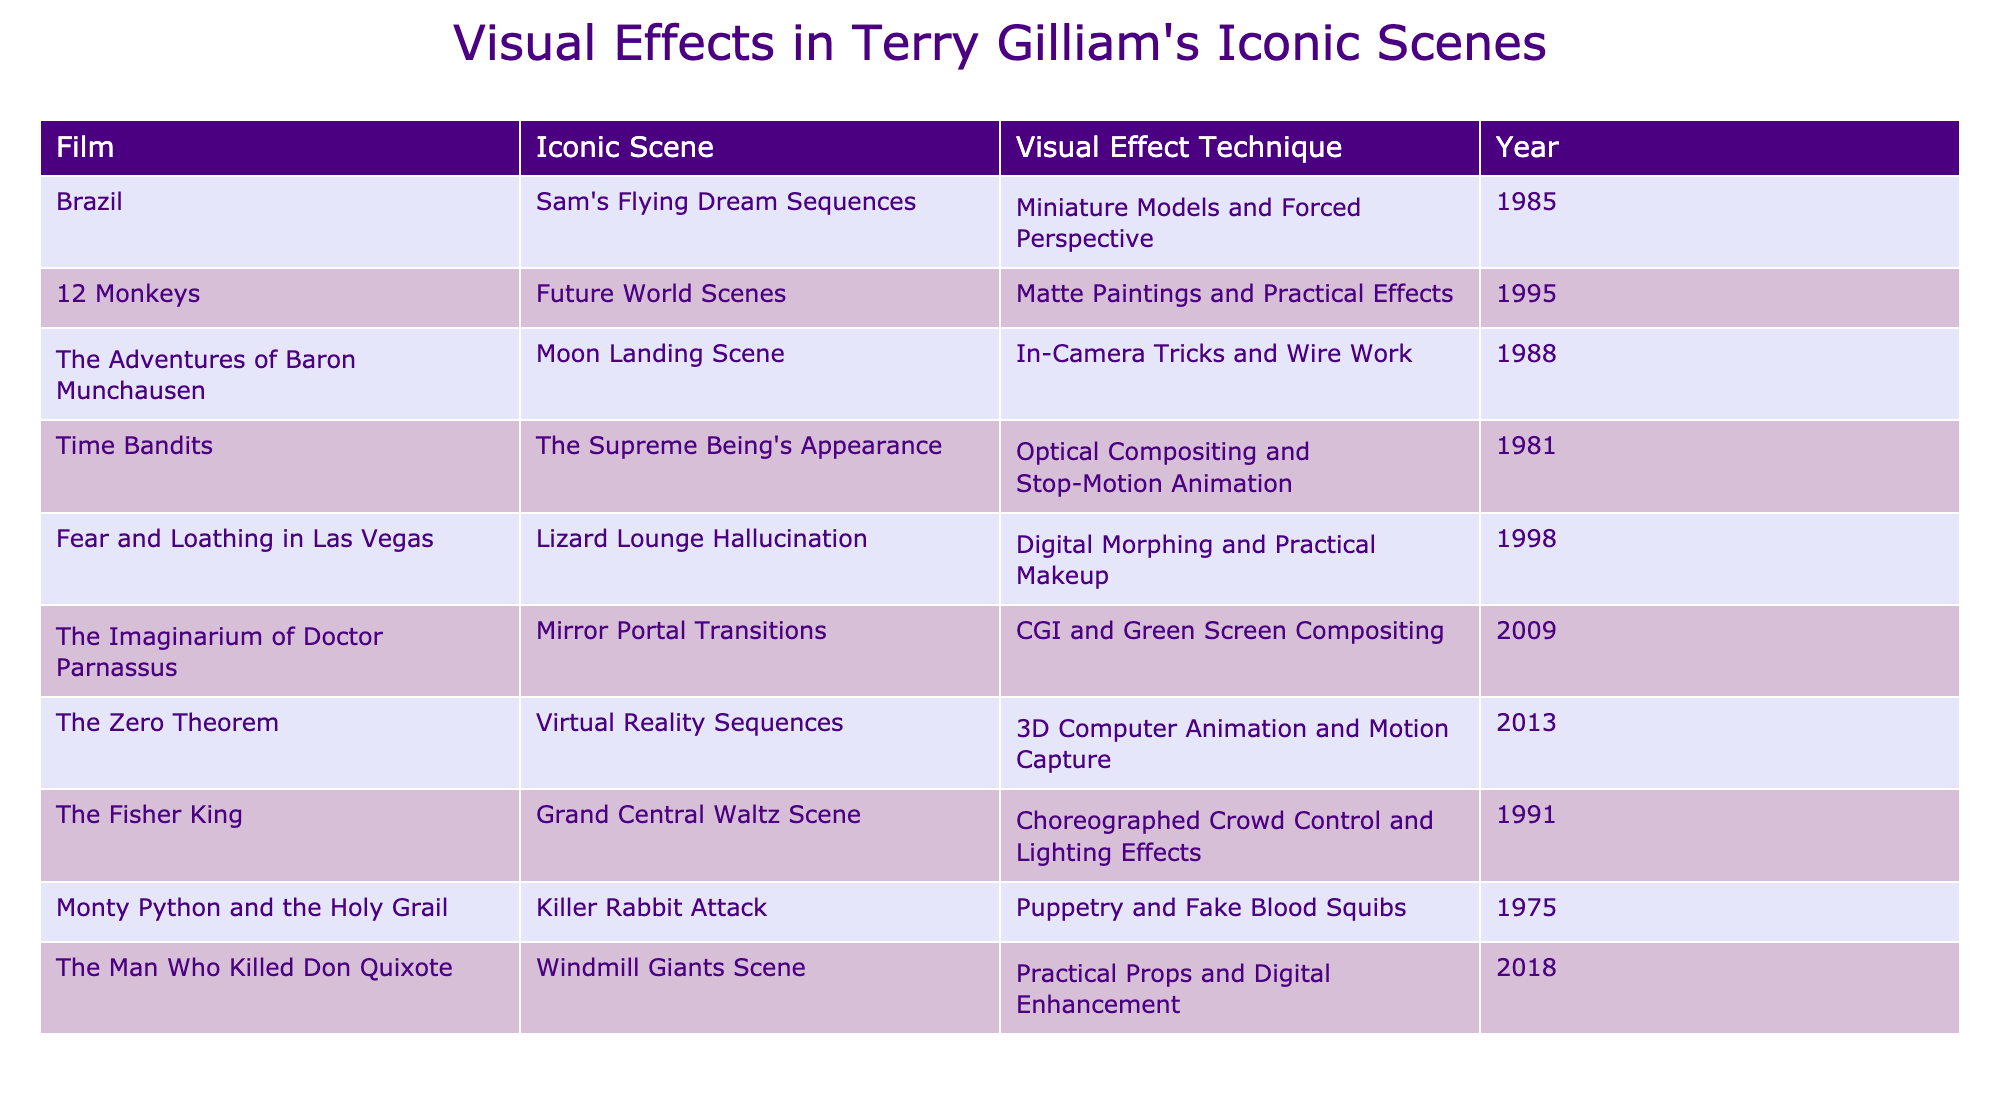What visual effect technique is used in Brazil's iconic scene? The table indicates that "Miniature Models and Forced Perspective" is the visual effect technique employed in the iconic scene of "Sam's Flying Dream Sequences" in the film "Brazil."
Answer: Miniature Models and Forced Perspective Which film employs practical effects in its iconic scene? The table provides information where the films that use practical effects include "12 Monkeys" with "Matte Paintings and Practical Effects" and "Fear and Loathing in Las Vegas" with "Digital Morphing and Practical Makeup." Therefore, the answer is "12 Monkeys" or "Fear and Loathing in Las Vegas."
Answer: 12 Monkeys or Fear and Loathing in Las Vegas How many films used CGI as a visual effect technique? Referring to the table, two films utilize CGI: "The Imaginarium of Doctor Parnassus" (CGI and Green Screen Compositing) and "The Zero Theorem" (3D Computer Animation and Motion Capture). Thus, the total number is 2.
Answer: 2 In which year was the moon landing scene from The Adventures of Baron Munchausen released? Looking at the table, "The Adventures of Baron Munchausen" and its "Moon Landing Scene" correspond to the year 1988.
Answer: 1988 Is there a film from 2013 that uses motion capture for visual effects? According to the table, "The Zero Theorem" is the film from 2013 that employs "3D Computer Animation and Motion Capture" as its visual effect technique. Therefore, the answer is yes.
Answer: Yes Which film features puppetry and fake blood squibs in its visual effects? The table shows that "Monty Python and the Holy Grail" employs "Puppetry and Fake Blood Squibs" in its iconic scene, which confirms this fact.
Answer: Monty Python and the Holy Grail What is the most recent film listed, and what visual effects technique did it use? The table lists "The Man Who Killed Don Quixote" as the most recent film released in 2018, which uses "Practical Props and Digital Enhancement" as its visual effects technique.
Answer: The Man Who Killed Don Quixote, Practical Props and Digital Enhancement What is the average year of release for the films listed in the table? To find this, we need to sum the years of all films: (1985 + 1995 + 1988 + 1981 + 1998 + 2009 + 2013 + 1991 + 1975 + 2018) = 19805, and there are 10 films, so the average year is 19805 / 10 = 1980.5, which we can round to 1981. Therefore, the average year is approximately 1981.
Answer: 1981 